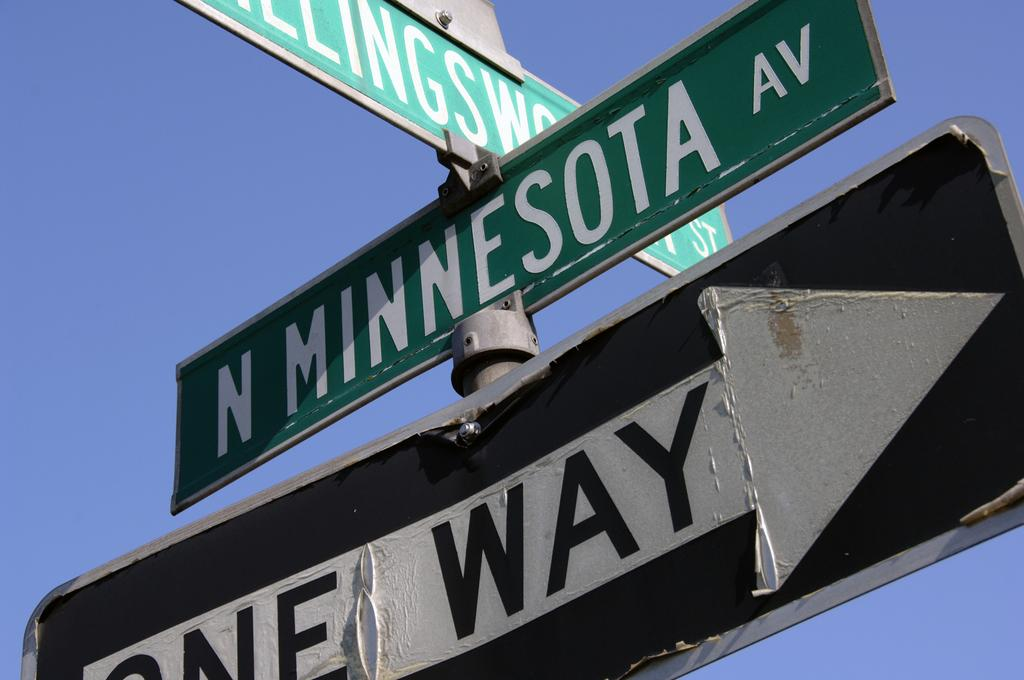<image>
Summarize the visual content of the image. N Minnesota Av. was the name of the street that is above the one way sign. 